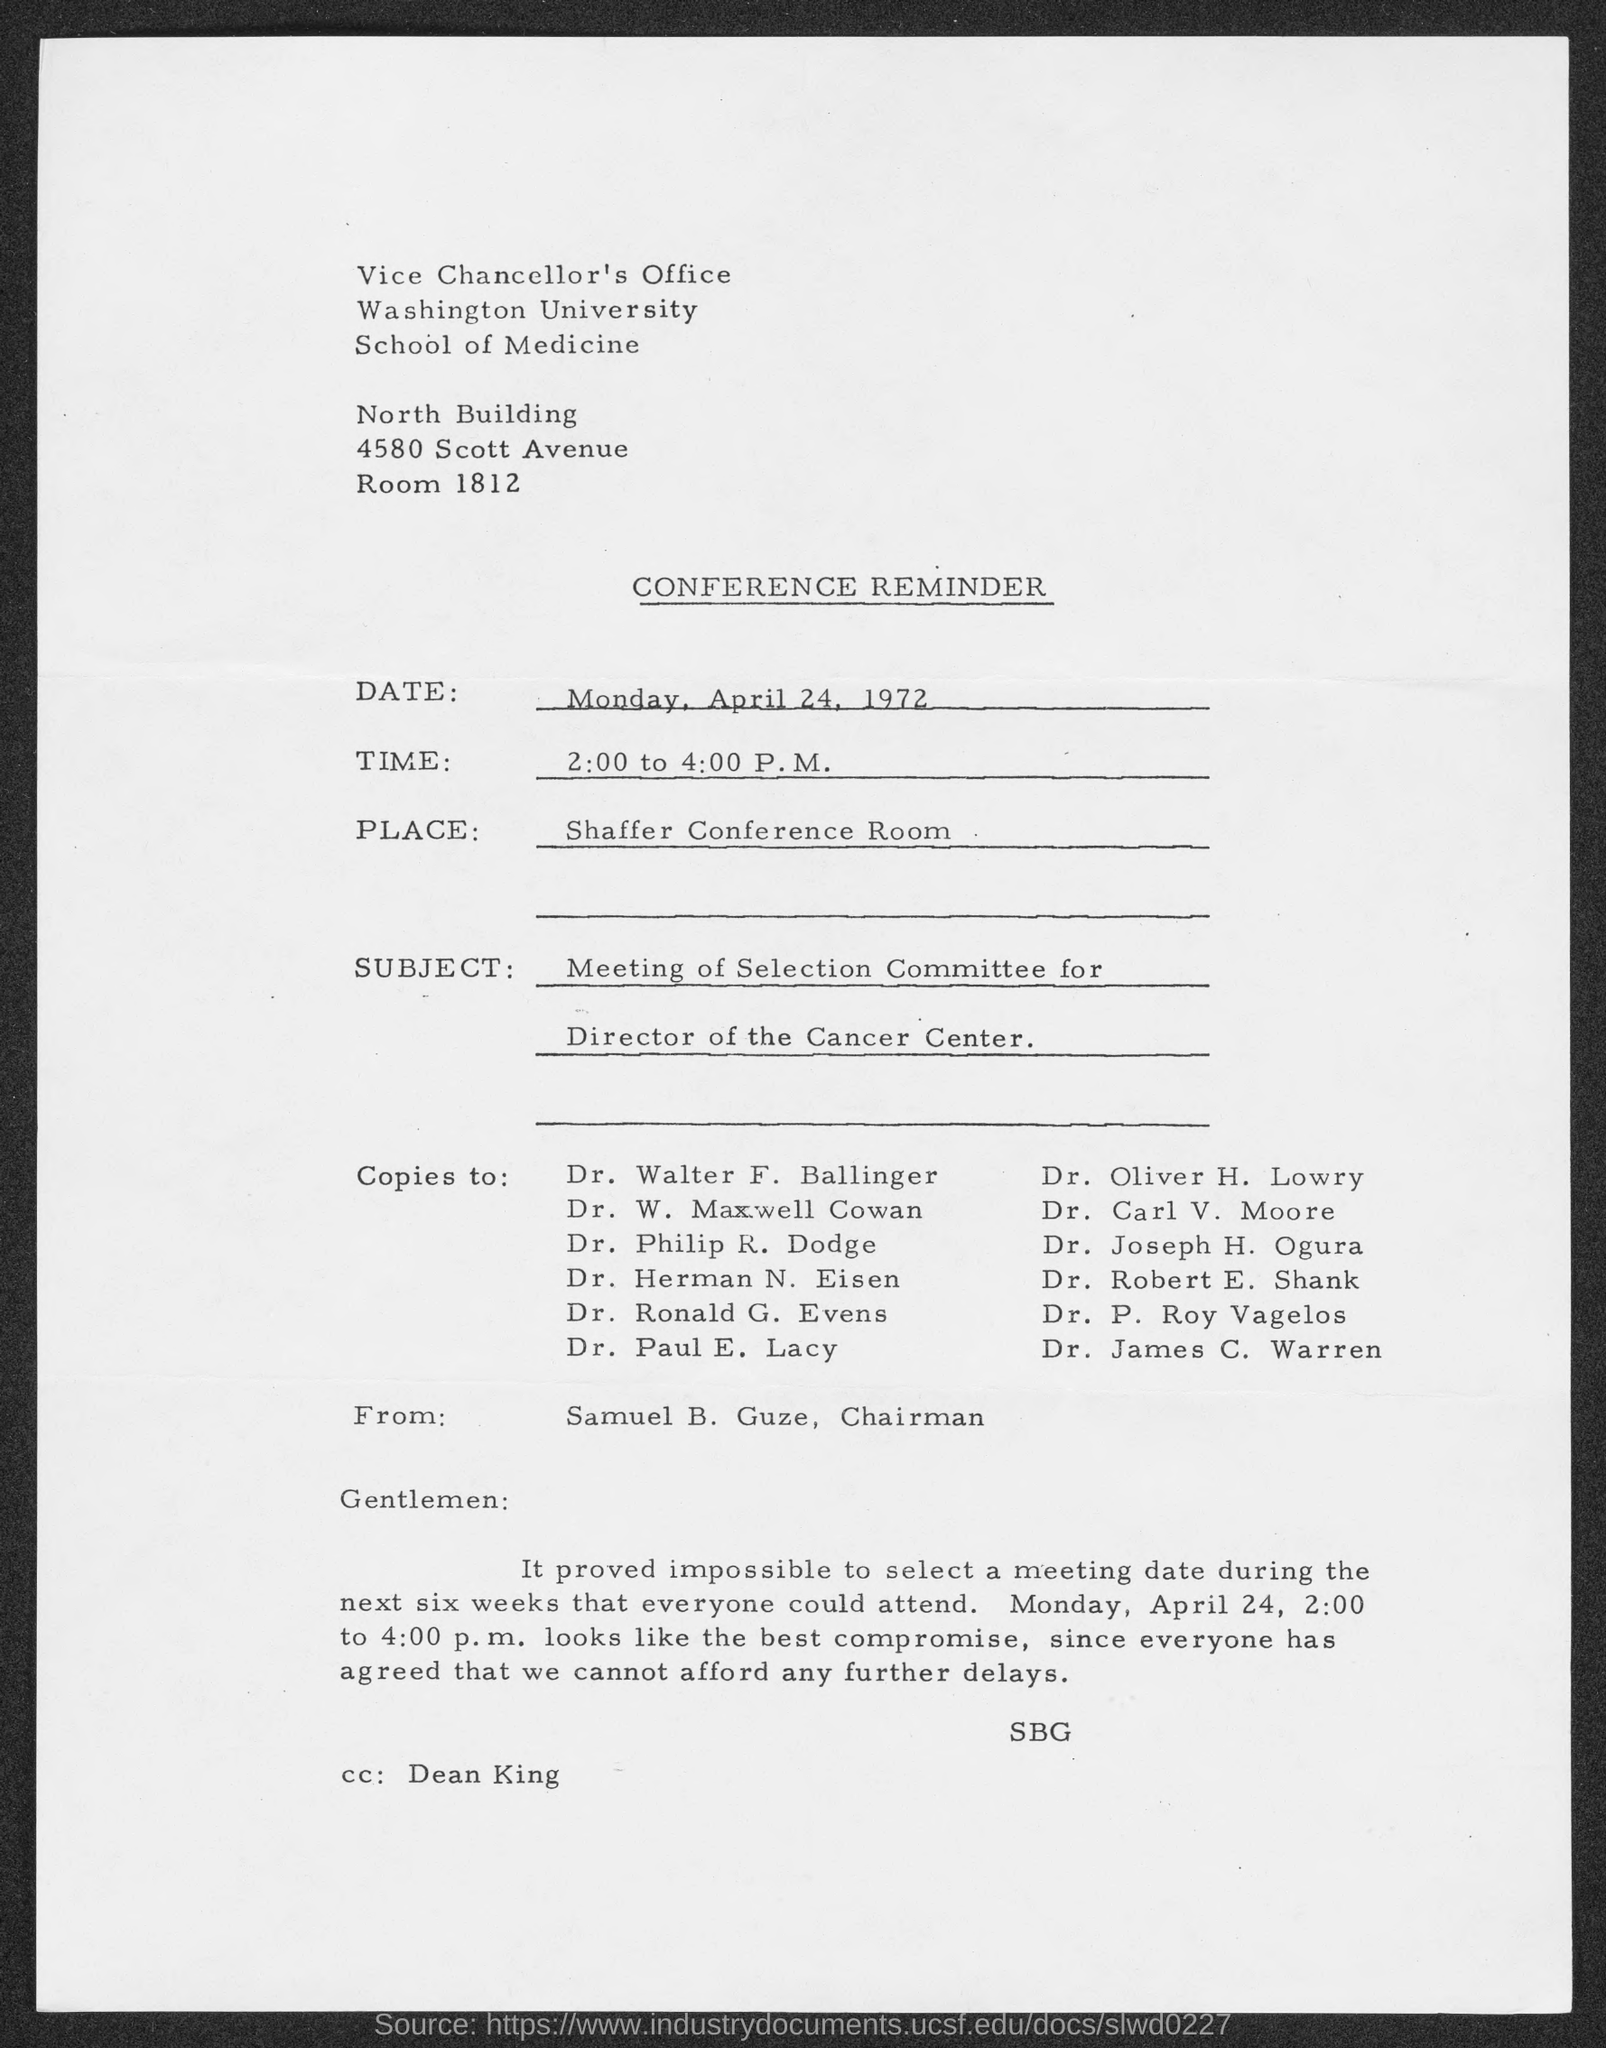What type of document is given here?
Your answer should be very brief. Conference Reminder. Who is the sender of this reminder?
Ensure brevity in your answer.  Samuel B. Guze, Chairman. What is the date of conference mentioned in the document?
Provide a succinct answer. Monday, April 24, 1972. Where is the conference meeting held as per the document?
Provide a succinct answer. Shaffer Conference Room. What is the subject mentioned in the conference reminder?
Offer a very short reply. Meeting of Selection Committee for Director of the Cancer Center. Who is mentioned in the CC of the conference reminder?
Your response must be concise. Dean King. 